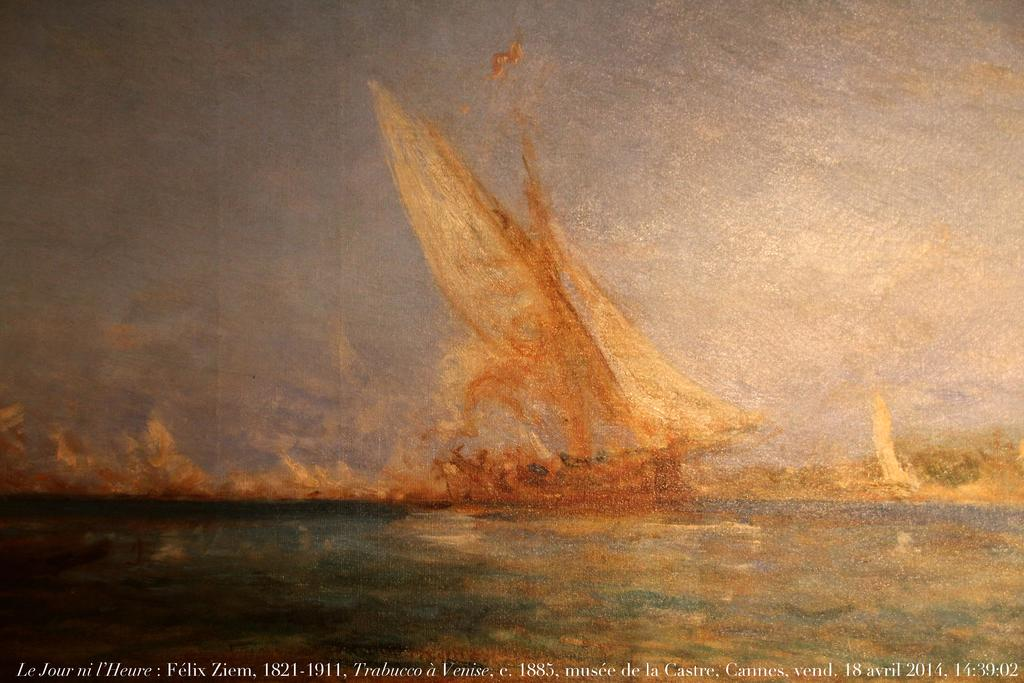<image>
Relay a brief, clear account of the picture shown. Picture of Le Jour ni Felix Ziem with a picture of a ship 